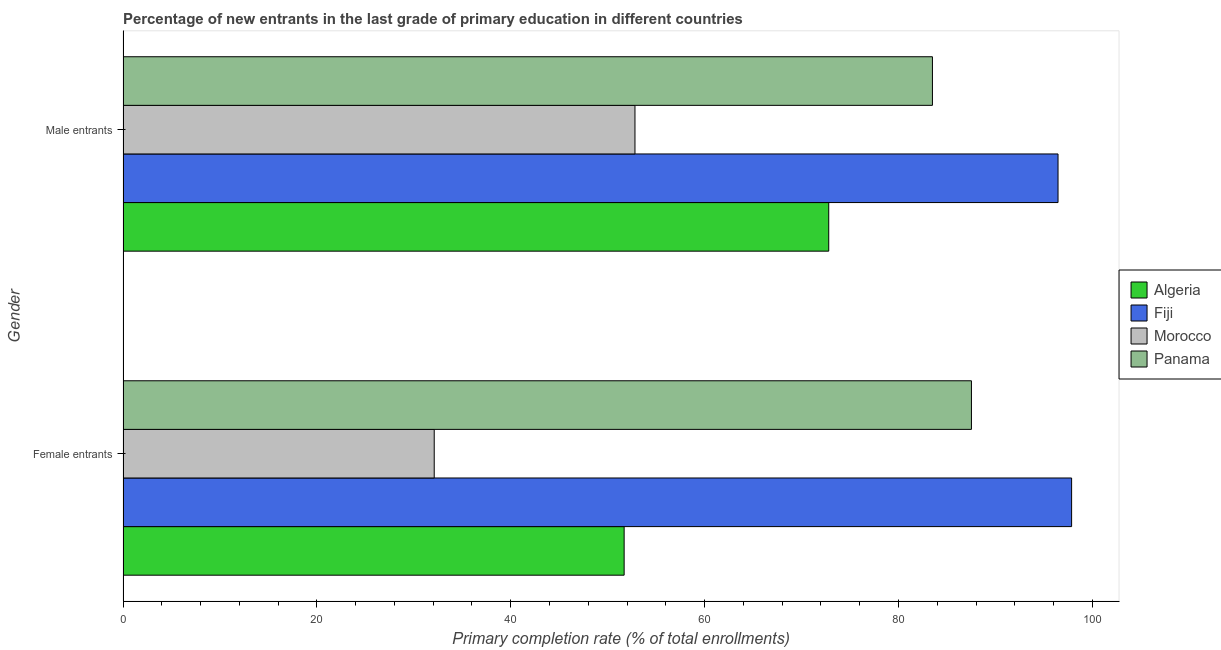How many groups of bars are there?
Provide a short and direct response. 2. Are the number of bars on each tick of the Y-axis equal?
Make the answer very short. Yes. How many bars are there on the 1st tick from the top?
Provide a short and direct response. 4. How many bars are there on the 2nd tick from the bottom?
Give a very brief answer. 4. What is the label of the 2nd group of bars from the top?
Provide a short and direct response. Female entrants. What is the primary completion rate of female entrants in Fiji?
Ensure brevity in your answer.  97.86. Across all countries, what is the maximum primary completion rate of female entrants?
Give a very brief answer. 97.86. Across all countries, what is the minimum primary completion rate of male entrants?
Ensure brevity in your answer.  52.81. In which country was the primary completion rate of female entrants maximum?
Your response must be concise. Fiji. In which country was the primary completion rate of male entrants minimum?
Offer a very short reply. Morocco. What is the total primary completion rate of female entrants in the graph?
Make the answer very short. 269.18. What is the difference between the primary completion rate of female entrants in Fiji and that in Panama?
Provide a succinct answer. 10.33. What is the difference between the primary completion rate of female entrants in Panama and the primary completion rate of male entrants in Algeria?
Give a very brief answer. 14.72. What is the average primary completion rate of male entrants per country?
Provide a short and direct response. 76.39. What is the difference between the primary completion rate of female entrants and primary completion rate of male entrants in Panama?
Provide a succinct answer. 4.02. In how many countries, is the primary completion rate of male entrants greater than 44 %?
Offer a terse response. 4. What is the ratio of the primary completion rate of male entrants in Morocco to that in Fiji?
Your response must be concise. 0.55. What does the 3rd bar from the top in Female entrants represents?
Ensure brevity in your answer.  Fiji. What does the 1st bar from the bottom in Female entrants represents?
Provide a short and direct response. Algeria. How many bars are there?
Offer a very short reply. 8. How many countries are there in the graph?
Make the answer very short. 4. How many legend labels are there?
Provide a succinct answer. 4. What is the title of the graph?
Provide a short and direct response. Percentage of new entrants in the last grade of primary education in different countries. What is the label or title of the X-axis?
Provide a succinct answer. Primary completion rate (% of total enrollments). What is the label or title of the Y-axis?
Your answer should be compact. Gender. What is the Primary completion rate (% of total enrollments) of Algeria in Female entrants?
Make the answer very short. 51.7. What is the Primary completion rate (% of total enrollments) in Fiji in Female entrants?
Offer a terse response. 97.86. What is the Primary completion rate (% of total enrollments) of Morocco in Female entrants?
Keep it short and to the point. 32.1. What is the Primary completion rate (% of total enrollments) in Panama in Female entrants?
Ensure brevity in your answer.  87.52. What is the Primary completion rate (% of total enrollments) of Algeria in Male entrants?
Provide a succinct answer. 72.8. What is the Primary completion rate (% of total enrollments) of Fiji in Male entrants?
Your answer should be compact. 96.46. What is the Primary completion rate (% of total enrollments) in Morocco in Male entrants?
Ensure brevity in your answer.  52.81. What is the Primary completion rate (% of total enrollments) in Panama in Male entrants?
Ensure brevity in your answer.  83.5. Across all Gender, what is the maximum Primary completion rate (% of total enrollments) of Algeria?
Your answer should be very brief. 72.8. Across all Gender, what is the maximum Primary completion rate (% of total enrollments) in Fiji?
Provide a short and direct response. 97.86. Across all Gender, what is the maximum Primary completion rate (% of total enrollments) of Morocco?
Offer a very short reply. 52.81. Across all Gender, what is the maximum Primary completion rate (% of total enrollments) of Panama?
Your response must be concise. 87.52. Across all Gender, what is the minimum Primary completion rate (% of total enrollments) in Algeria?
Ensure brevity in your answer.  51.7. Across all Gender, what is the minimum Primary completion rate (% of total enrollments) of Fiji?
Make the answer very short. 96.46. Across all Gender, what is the minimum Primary completion rate (% of total enrollments) in Morocco?
Offer a very short reply. 32.1. Across all Gender, what is the minimum Primary completion rate (% of total enrollments) in Panama?
Offer a very short reply. 83.5. What is the total Primary completion rate (% of total enrollments) of Algeria in the graph?
Provide a short and direct response. 124.5. What is the total Primary completion rate (% of total enrollments) in Fiji in the graph?
Offer a very short reply. 194.31. What is the total Primary completion rate (% of total enrollments) of Morocco in the graph?
Provide a short and direct response. 84.92. What is the total Primary completion rate (% of total enrollments) of Panama in the graph?
Your response must be concise. 171.02. What is the difference between the Primary completion rate (% of total enrollments) of Algeria in Female entrants and that in Male entrants?
Your response must be concise. -21.1. What is the difference between the Primary completion rate (% of total enrollments) in Fiji in Female entrants and that in Male entrants?
Offer a very short reply. 1.4. What is the difference between the Primary completion rate (% of total enrollments) of Morocco in Female entrants and that in Male entrants?
Ensure brevity in your answer.  -20.71. What is the difference between the Primary completion rate (% of total enrollments) of Panama in Female entrants and that in Male entrants?
Provide a succinct answer. 4.02. What is the difference between the Primary completion rate (% of total enrollments) in Algeria in Female entrants and the Primary completion rate (% of total enrollments) in Fiji in Male entrants?
Provide a succinct answer. -44.76. What is the difference between the Primary completion rate (% of total enrollments) in Algeria in Female entrants and the Primary completion rate (% of total enrollments) in Morocco in Male entrants?
Provide a short and direct response. -1.12. What is the difference between the Primary completion rate (% of total enrollments) in Algeria in Female entrants and the Primary completion rate (% of total enrollments) in Panama in Male entrants?
Your answer should be very brief. -31.8. What is the difference between the Primary completion rate (% of total enrollments) of Fiji in Female entrants and the Primary completion rate (% of total enrollments) of Morocco in Male entrants?
Keep it short and to the point. 45.04. What is the difference between the Primary completion rate (% of total enrollments) in Fiji in Female entrants and the Primary completion rate (% of total enrollments) in Panama in Male entrants?
Offer a terse response. 14.36. What is the difference between the Primary completion rate (% of total enrollments) in Morocco in Female entrants and the Primary completion rate (% of total enrollments) in Panama in Male entrants?
Ensure brevity in your answer.  -51.39. What is the average Primary completion rate (% of total enrollments) in Algeria per Gender?
Your answer should be very brief. 62.25. What is the average Primary completion rate (% of total enrollments) of Fiji per Gender?
Offer a terse response. 97.16. What is the average Primary completion rate (% of total enrollments) of Morocco per Gender?
Your response must be concise. 42.46. What is the average Primary completion rate (% of total enrollments) of Panama per Gender?
Keep it short and to the point. 85.51. What is the difference between the Primary completion rate (% of total enrollments) in Algeria and Primary completion rate (% of total enrollments) in Fiji in Female entrants?
Keep it short and to the point. -46.16. What is the difference between the Primary completion rate (% of total enrollments) of Algeria and Primary completion rate (% of total enrollments) of Morocco in Female entrants?
Ensure brevity in your answer.  19.59. What is the difference between the Primary completion rate (% of total enrollments) in Algeria and Primary completion rate (% of total enrollments) in Panama in Female entrants?
Keep it short and to the point. -35.82. What is the difference between the Primary completion rate (% of total enrollments) in Fiji and Primary completion rate (% of total enrollments) in Morocco in Female entrants?
Give a very brief answer. 65.75. What is the difference between the Primary completion rate (% of total enrollments) of Fiji and Primary completion rate (% of total enrollments) of Panama in Female entrants?
Ensure brevity in your answer.  10.33. What is the difference between the Primary completion rate (% of total enrollments) in Morocco and Primary completion rate (% of total enrollments) in Panama in Female entrants?
Provide a short and direct response. -55.42. What is the difference between the Primary completion rate (% of total enrollments) in Algeria and Primary completion rate (% of total enrollments) in Fiji in Male entrants?
Give a very brief answer. -23.65. What is the difference between the Primary completion rate (% of total enrollments) in Algeria and Primary completion rate (% of total enrollments) in Morocco in Male entrants?
Give a very brief answer. 19.99. What is the difference between the Primary completion rate (% of total enrollments) in Algeria and Primary completion rate (% of total enrollments) in Panama in Male entrants?
Make the answer very short. -10.7. What is the difference between the Primary completion rate (% of total enrollments) of Fiji and Primary completion rate (% of total enrollments) of Morocco in Male entrants?
Your answer should be very brief. 43.64. What is the difference between the Primary completion rate (% of total enrollments) in Fiji and Primary completion rate (% of total enrollments) in Panama in Male entrants?
Give a very brief answer. 12.96. What is the difference between the Primary completion rate (% of total enrollments) in Morocco and Primary completion rate (% of total enrollments) in Panama in Male entrants?
Keep it short and to the point. -30.68. What is the ratio of the Primary completion rate (% of total enrollments) in Algeria in Female entrants to that in Male entrants?
Ensure brevity in your answer.  0.71. What is the ratio of the Primary completion rate (% of total enrollments) of Fiji in Female entrants to that in Male entrants?
Offer a terse response. 1.01. What is the ratio of the Primary completion rate (% of total enrollments) in Morocco in Female entrants to that in Male entrants?
Offer a very short reply. 0.61. What is the ratio of the Primary completion rate (% of total enrollments) of Panama in Female entrants to that in Male entrants?
Provide a succinct answer. 1.05. What is the difference between the highest and the second highest Primary completion rate (% of total enrollments) in Algeria?
Make the answer very short. 21.1. What is the difference between the highest and the second highest Primary completion rate (% of total enrollments) in Fiji?
Give a very brief answer. 1.4. What is the difference between the highest and the second highest Primary completion rate (% of total enrollments) of Morocco?
Offer a terse response. 20.71. What is the difference between the highest and the second highest Primary completion rate (% of total enrollments) of Panama?
Your answer should be very brief. 4.02. What is the difference between the highest and the lowest Primary completion rate (% of total enrollments) in Algeria?
Offer a terse response. 21.1. What is the difference between the highest and the lowest Primary completion rate (% of total enrollments) in Fiji?
Provide a short and direct response. 1.4. What is the difference between the highest and the lowest Primary completion rate (% of total enrollments) of Morocco?
Provide a succinct answer. 20.71. What is the difference between the highest and the lowest Primary completion rate (% of total enrollments) in Panama?
Your response must be concise. 4.02. 